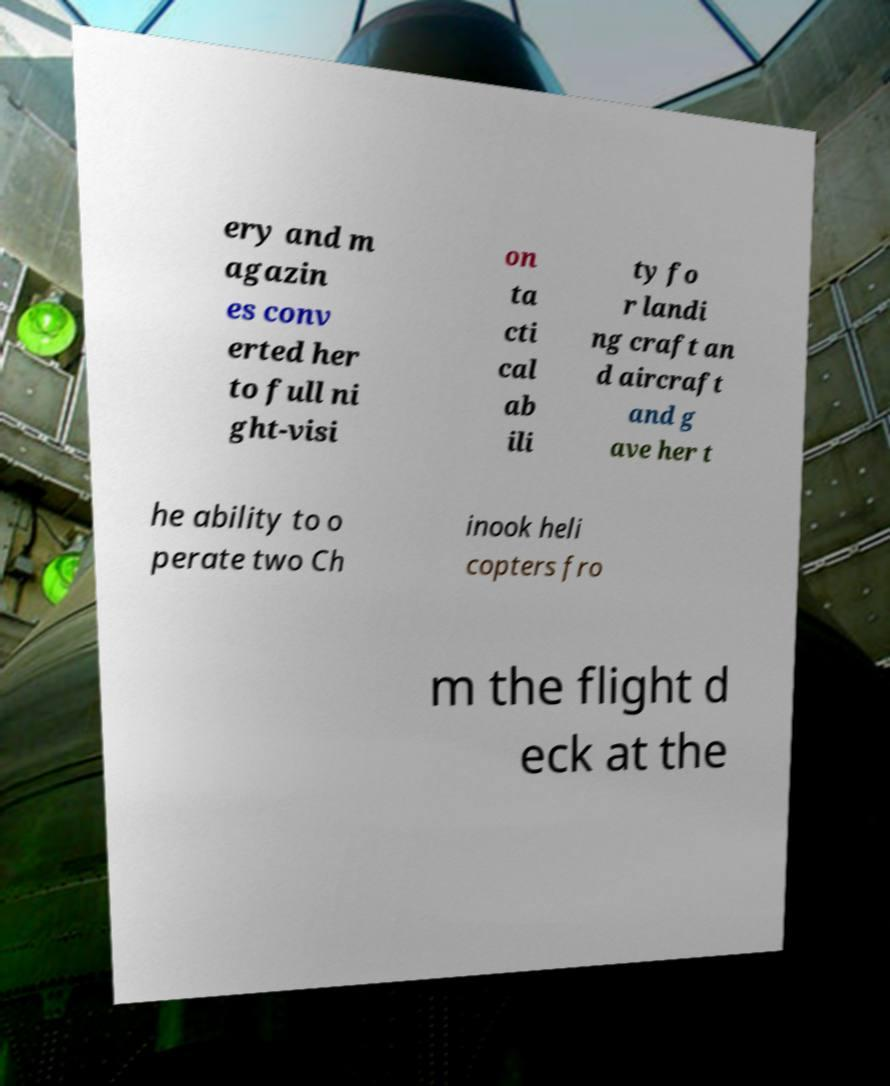What messages or text are displayed in this image? I need them in a readable, typed format. ery and m agazin es conv erted her to full ni ght-visi on ta cti cal ab ili ty fo r landi ng craft an d aircraft and g ave her t he ability to o perate two Ch inook heli copters fro m the flight d eck at the 